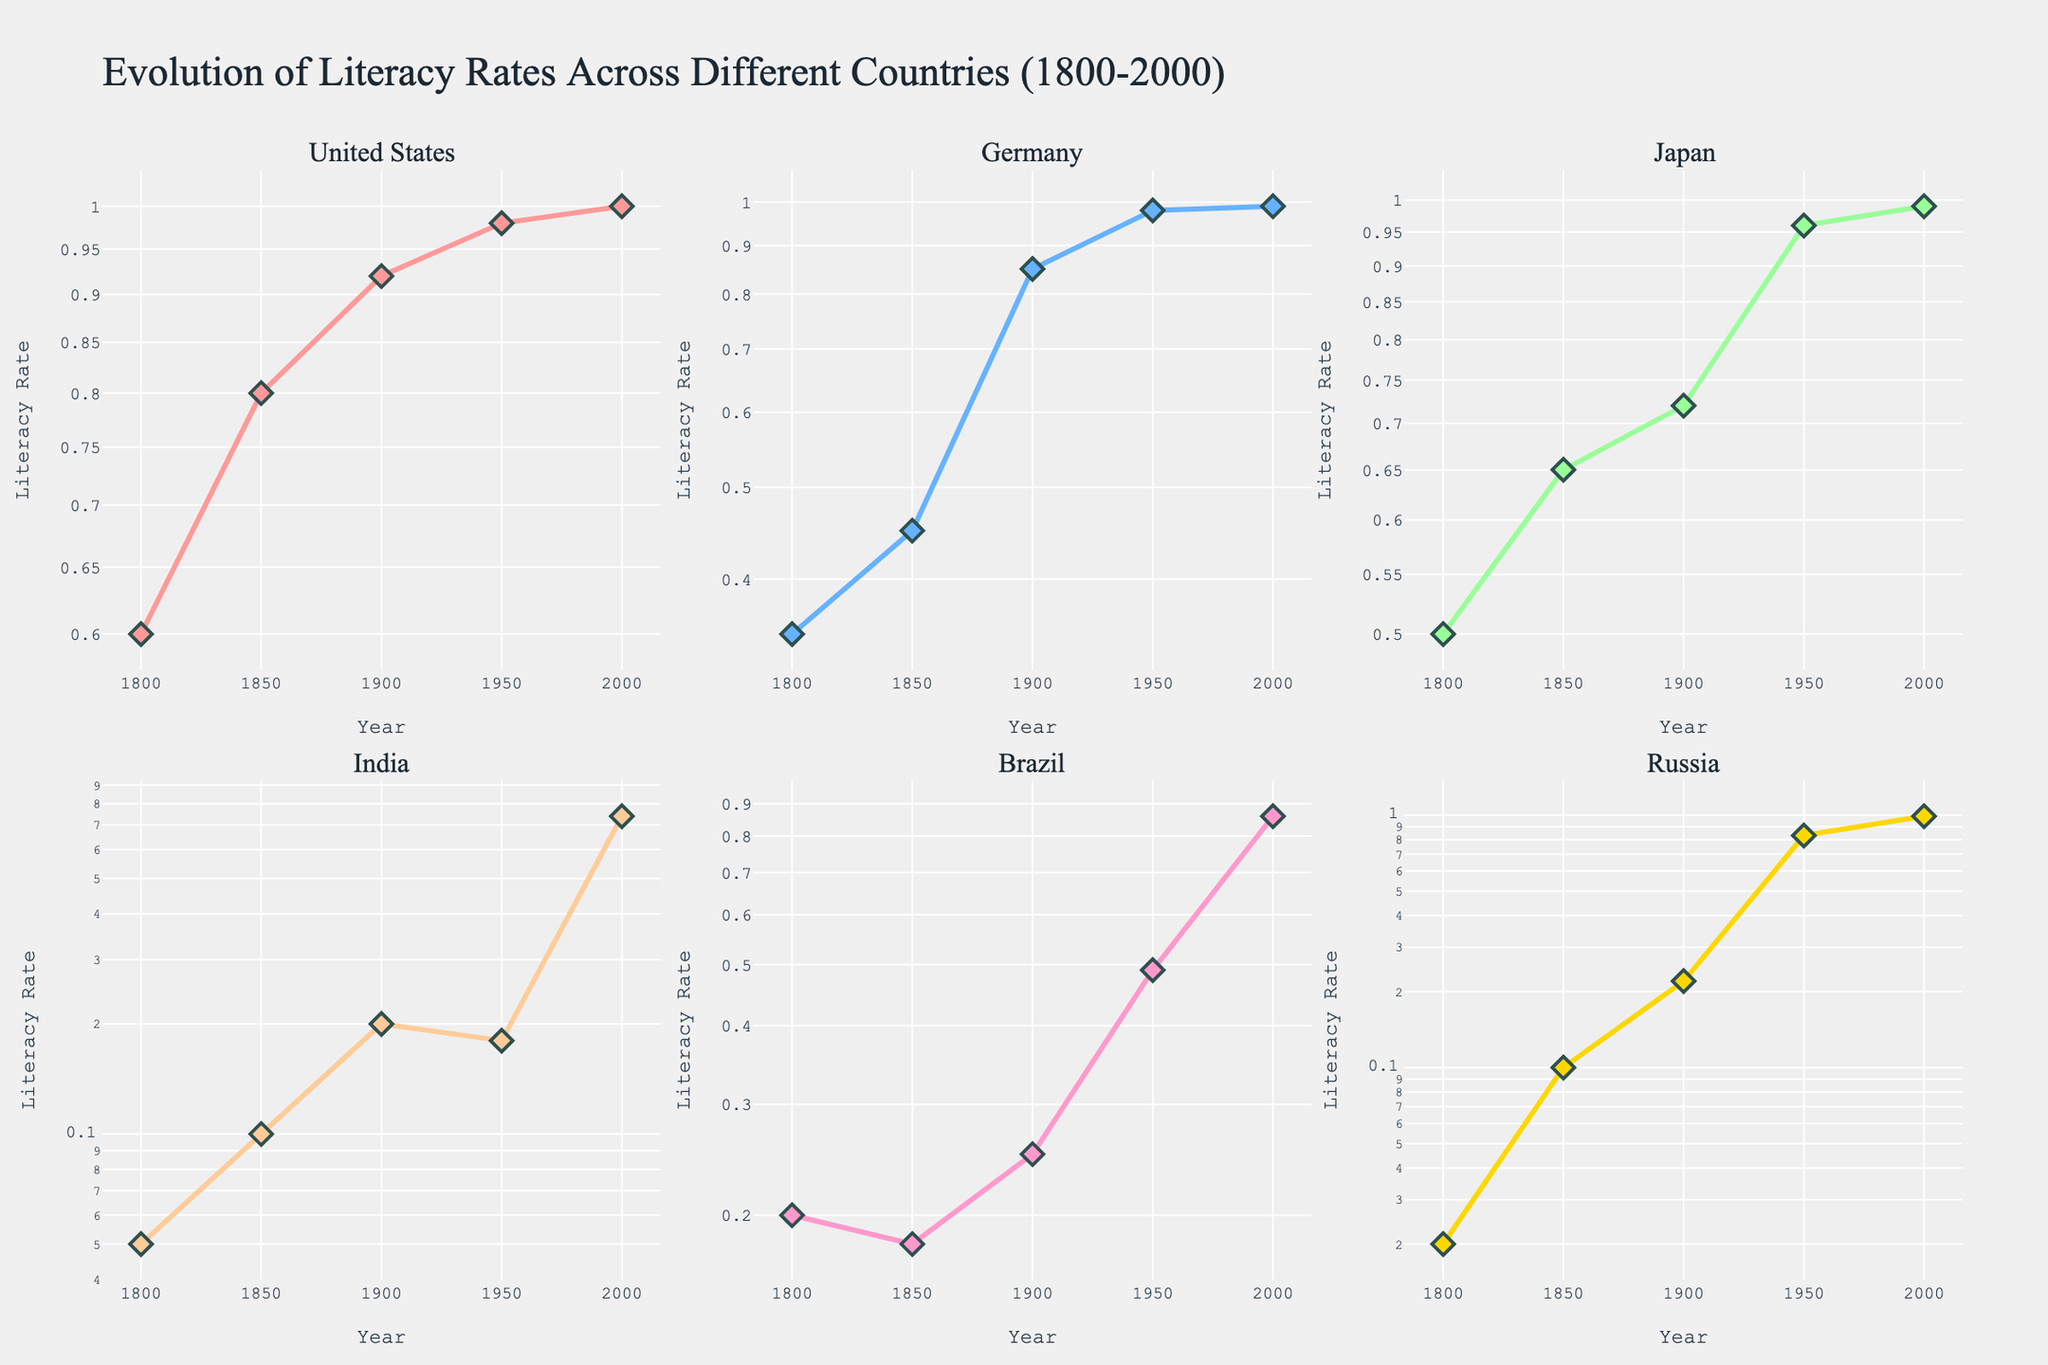How many countries are shown in the figure? The subplot titles represent different countries, and there are six titles implying there are six countries displayed.
Answer: Six What is the overall trend in literacy rates for Germany from 1800 to 2000? Observing Germany’s plot, the literacy rate increases consistently from 0.35 in 1800 to 0.99 in 2000.
Answer: Increasing Which country had the lowest literacy rate around 1800? In the plot, Russia starts at 0.02 in 1800, which is lower than the starting literacy rates of the other countries.
Answer: Russia Between 1900 and 1950, which country showed the most significant increase in literacy rate? From the plots, we can see significant jumps: Russia increased from 0.22 to 0.83, which is a difference of 0.61. This is higher compared to other countries in that interval.
Answer: Russia What can you say about the literacy rate trends in Japan compared to Brazil from 1950 to 2000? From 1950 to 2000, Japan's literacy rate increased from 0.96 to 0.99, which is a smaller increment compared to Brazil's rate, which grew from 0.49 to 0.86.
Answer: Japan showed a smaller increase compared to Brazil What is the difference in literacy rates between India and Germany in the year 1900? Germany has a literacy rate of 0.85 in 1900 and India has 0.20; the difference is calculated by 0.85 - 0.20.
Answer: 0.65 Compare the literacy rates in 1950 for the United States and India. What can you infer? In 1950, the United States has a literacy rate of 0.98, whereas India has 0.18. The United States had a much higher rate during this year.
Answer: The United States had a significantly higher literacy rate than India in 1950 Which country reached nearly 100% literacy rate first based on the plots? Examining the year labels, the United States and Germany both reached close to 100% literacy rate around 1950.
Answer: United States and Germany Identify the country with the most fluctuating literacy rates over the years. Looking at the plots, India has more fluctuations, especially during 1850 and 1900, where rates don't rise consistently.
Answer: India Is there a country that shows a literacy rate drop between any two successive periods? Observing the plots, Brazil shows a slight drop from 0.20 in 1800 to 0.18 in 1850.
Answer: Brazil 